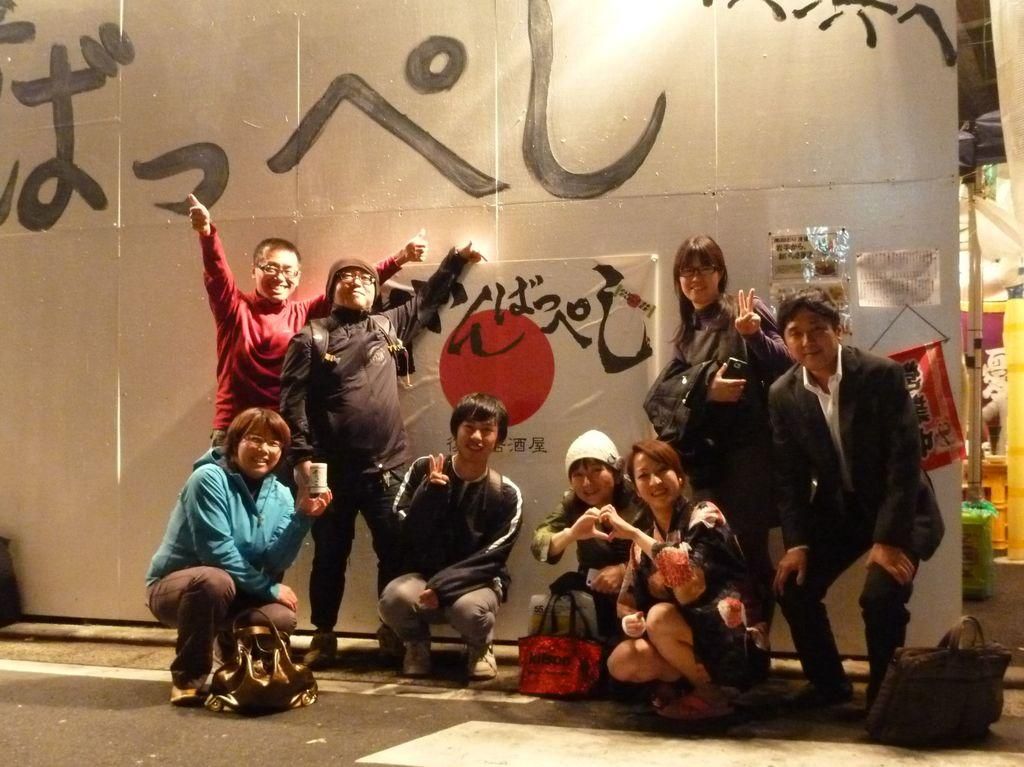How many people are in the image? There are people in the image, but the exact number is not specified. What are some people wearing in the image? Some people are wearing caps in the image. What are some people carrying in the image? Some people are carrying bags in the image. What can be seen in the background of the image? There is a wall in the background of the image. What is on the wall in the image? There is a banner on the wall in the image. What is written on the banner in the image? There is text written on the banner in the image. Can you tell me how many beetles are crawling on the banner in the image? There are no beetles present in the image, so it is not possible to determine how many would be crawling on the banner. 